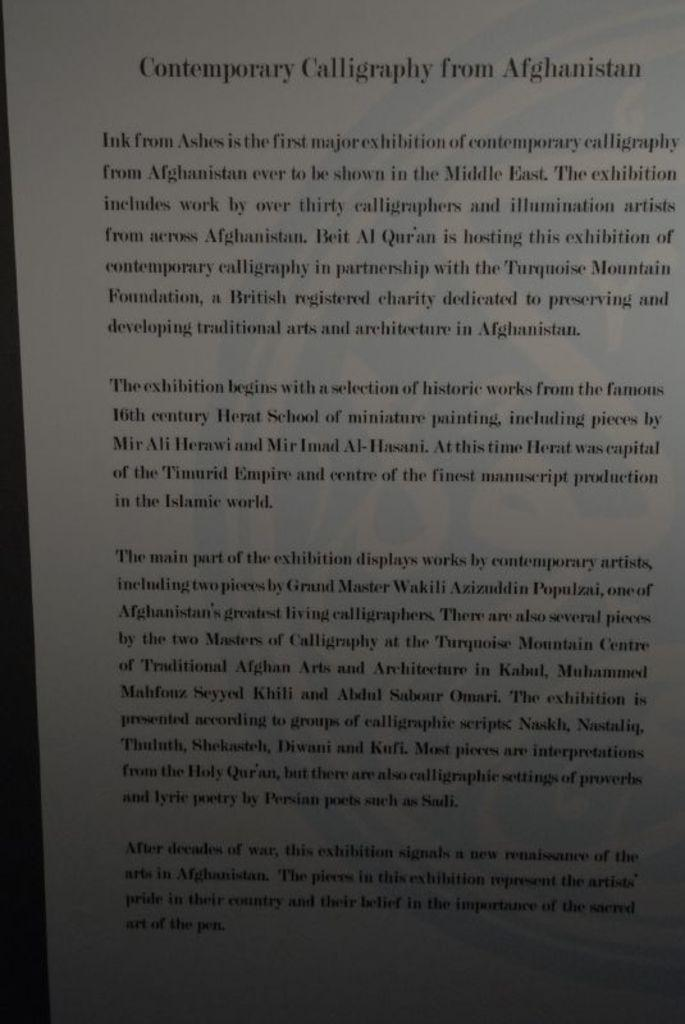Provide a one-sentence caption for the provided image. A page of a book labeled Contemporary Calligraphy of Afghanistan. 